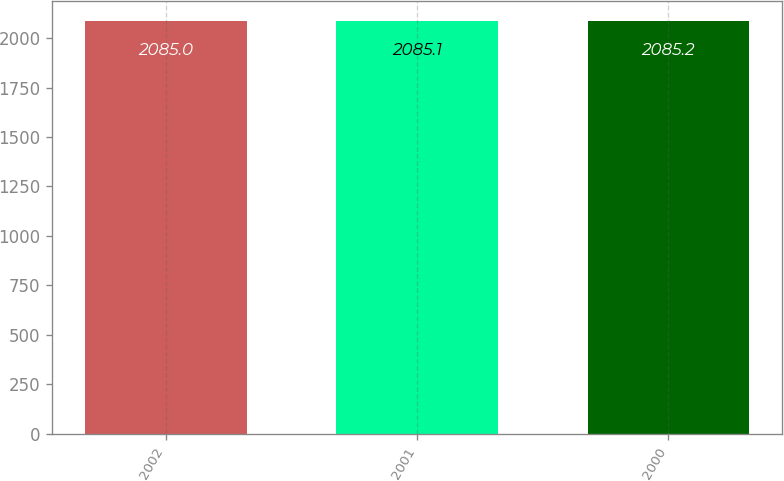Convert chart to OTSL. <chart><loc_0><loc_0><loc_500><loc_500><bar_chart><fcel>2002<fcel>2001<fcel>2000<nl><fcel>2085<fcel>2085.1<fcel>2085.2<nl></chart> 